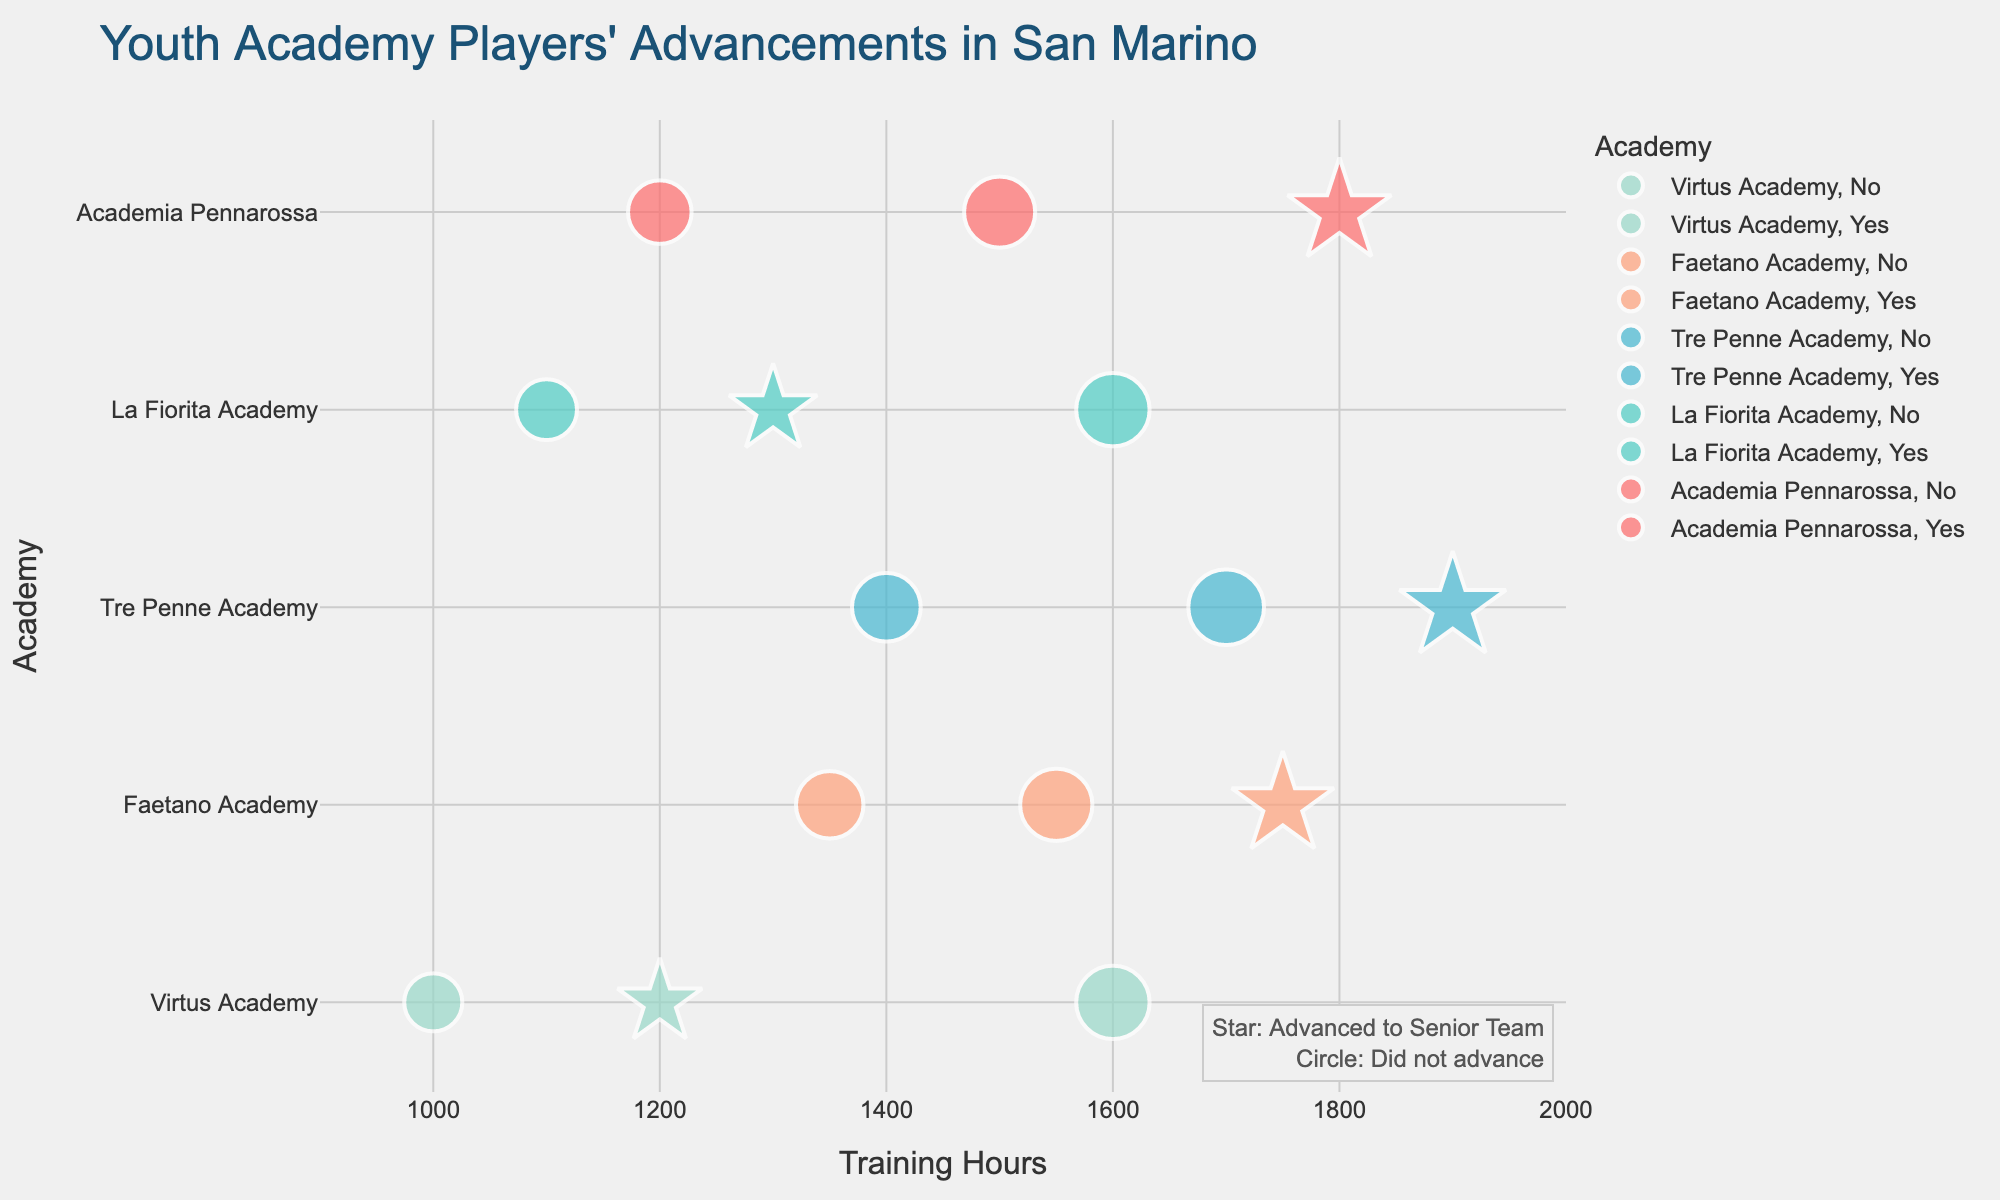What's the title of the figure? The title of the figure is prominently displayed at the top of the visualization, usually in a larger and bolder font.
Answer: Youth Academy Players' Advancements in San Marino How many players are from Academia Pennarossa? To find out, we look at the legend or color distinction for Academia Pennarossa and count the corresponding data points in the scatter plot.
Answer: 3 Which academy has the highest training hours recorded by a player who did not advance to the senior team? Identify the data points where the symbol is a circle (indicating no advancement) and check the training hours for each, then see which academy it belongs to.
Answer: Tre Penne Academy (Enrico Fabbri, 1400 hours) What's the average training hours for players who advanced to the senior team from Tre Penne Academy? We have two players from Tre Penne Academy who advanced (1700 and 1900 hours). The average is calculated by summing these values and dividing by the number of players. (1700 + 1900) = 3600 / 2 = 1800
Answer: 1800 Compare the training hours of players who advanced to the senior team from La Fiorita Academy and Faetano Academy. Which academy's players have higher average training hours? Calculate the average training hours for players from each academy who advanced. La Fiorita has one player (1600 hours), and Faetano Academy has two (1550 and 1750 hours). Average for Faetano: (1550 + 1750) / 2 = 1650. Compare averages: 1600 < 1650.
Answer: Faetano Academy What's the difference in training hours between the player with the highest and lowest training hours in Virtus Academy? Identify the training hours for players from Virtus Academy (1000, 1200, 1600 hours). The difference is calculated as 1600 - 1000.
Answer: 600 How many academies have players who did not advance to the senior team with over 1200 training hours? Locate the data points with circles (indicating no advancement) and training hours over 1200, then count the distinct academies.
Answer: 3 (Academia Pennarossa, Tre Penne Academy, Faetano Academy) Which player trained for the fewest hours and did they advance to the senior team? Identify the player with the minimum training hours from the data points and check the symbol to determine advancement status.
Answer: Riccardo Berti, No What's the total number of players who have advanced to the senior team from all academies? Count the total number of star symbols in the scatter plot.
Answer: 8 Compare the number of players who did not advance to the senior team between Academia Pennarossa and Virtus Academy. Which academy has more? Count the circle symbols (indicating no advancement) for both academies and compare the counts. Academia Pennarossa has 1, Virtus Academy has 2.
Answer: Virtus Academy 